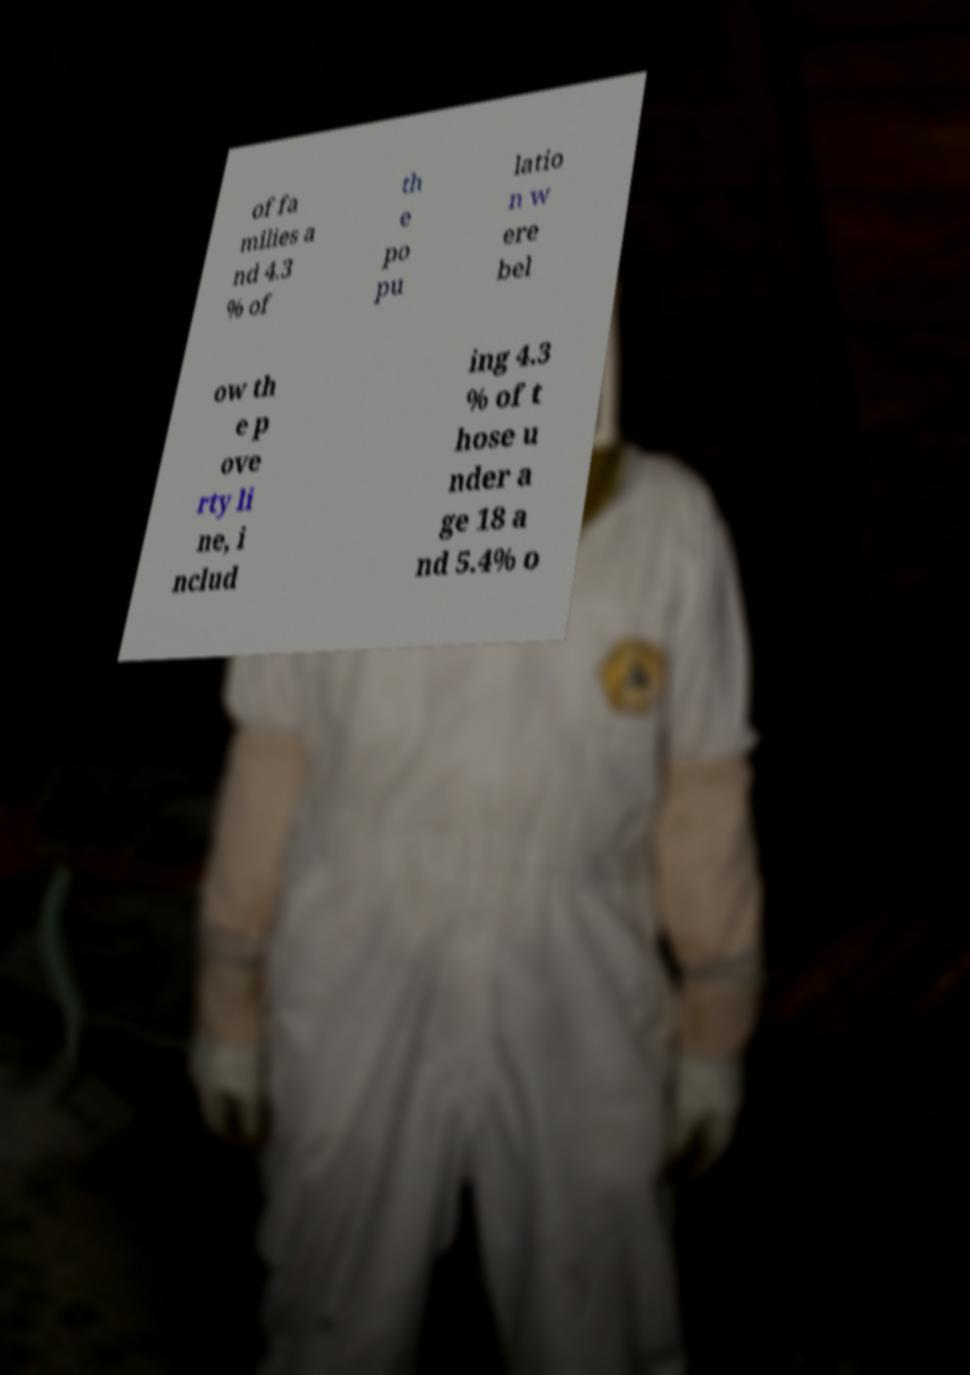Please identify and transcribe the text found in this image. of fa milies a nd 4.3 % of th e po pu latio n w ere bel ow th e p ove rty li ne, i nclud ing 4.3 % of t hose u nder a ge 18 a nd 5.4% o 